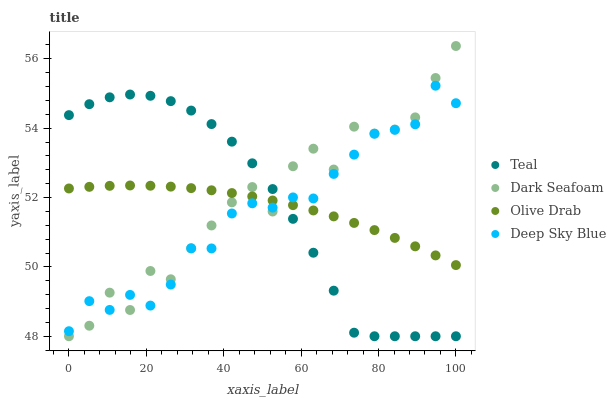Does Deep Sky Blue have the minimum area under the curve?
Answer yes or no. Yes. Does Dark Seafoam have the maximum area under the curve?
Answer yes or no. Yes. Does Olive Drab have the minimum area under the curve?
Answer yes or no. No. Does Olive Drab have the maximum area under the curve?
Answer yes or no. No. Is Olive Drab the smoothest?
Answer yes or no. Yes. Is Dark Seafoam the roughest?
Answer yes or no. Yes. Is Dark Seafoam the smoothest?
Answer yes or no. No. Is Olive Drab the roughest?
Answer yes or no. No. Does Dark Seafoam have the lowest value?
Answer yes or no. Yes. Does Olive Drab have the lowest value?
Answer yes or no. No. Does Dark Seafoam have the highest value?
Answer yes or no. Yes. Does Olive Drab have the highest value?
Answer yes or no. No. Does Teal intersect Deep Sky Blue?
Answer yes or no. Yes. Is Teal less than Deep Sky Blue?
Answer yes or no. No. Is Teal greater than Deep Sky Blue?
Answer yes or no. No. 